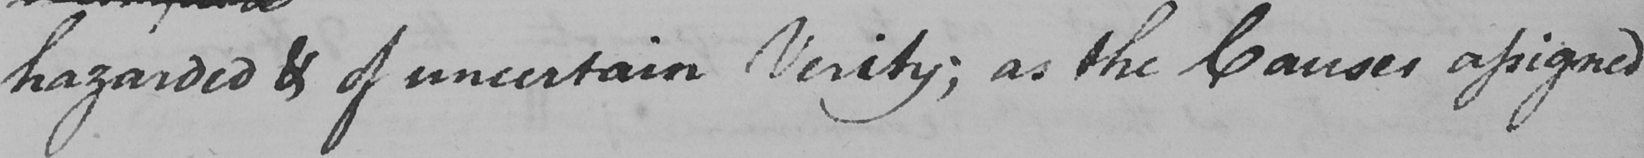Can you tell me what this handwritten text says? hazarded & of uncertain Verity ; as the Causes assigned 